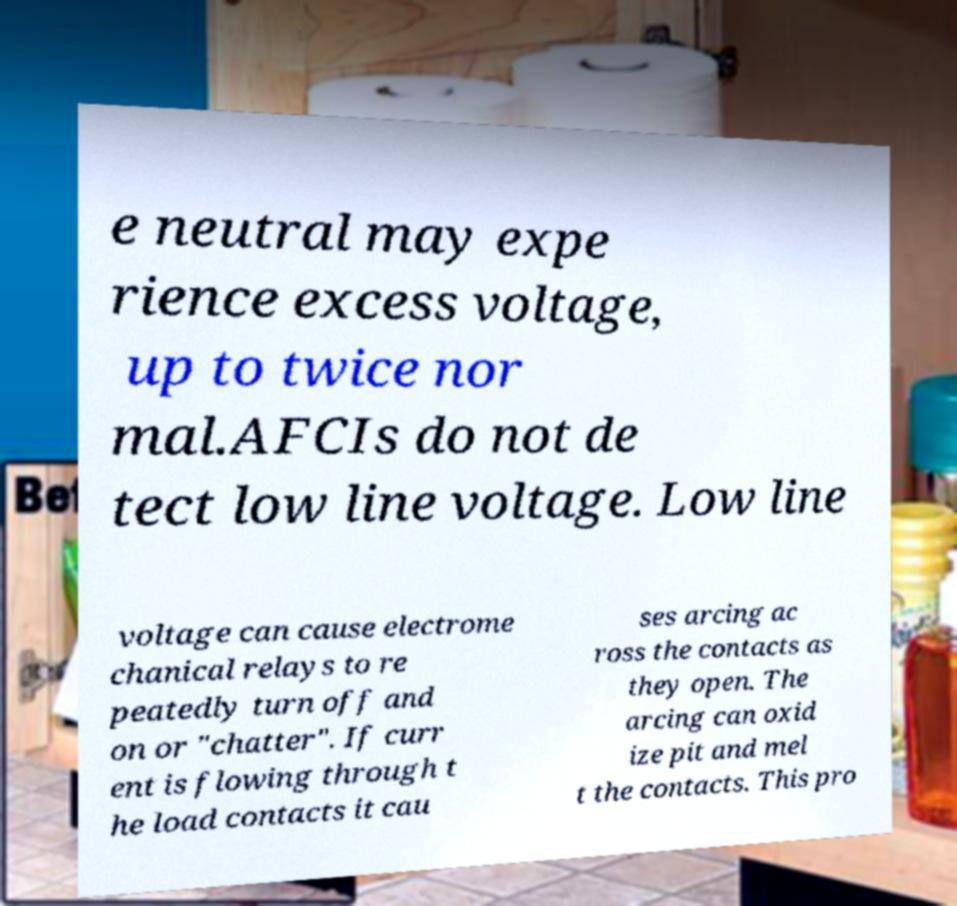Could you extract and type out the text from this image? e neutral may expe rience excess voltage, up to twice nor mal.AFCIs do not de tect low line voltage. Low line voltage can cause electrome chanical relays to re peatedly turn off and on or "chatter". If curr ent is flowing through t he load contacts it cau ses arcing ac ross the contacts as they open. The arcing can oxid ize pit and mel t the contacts. This pro 